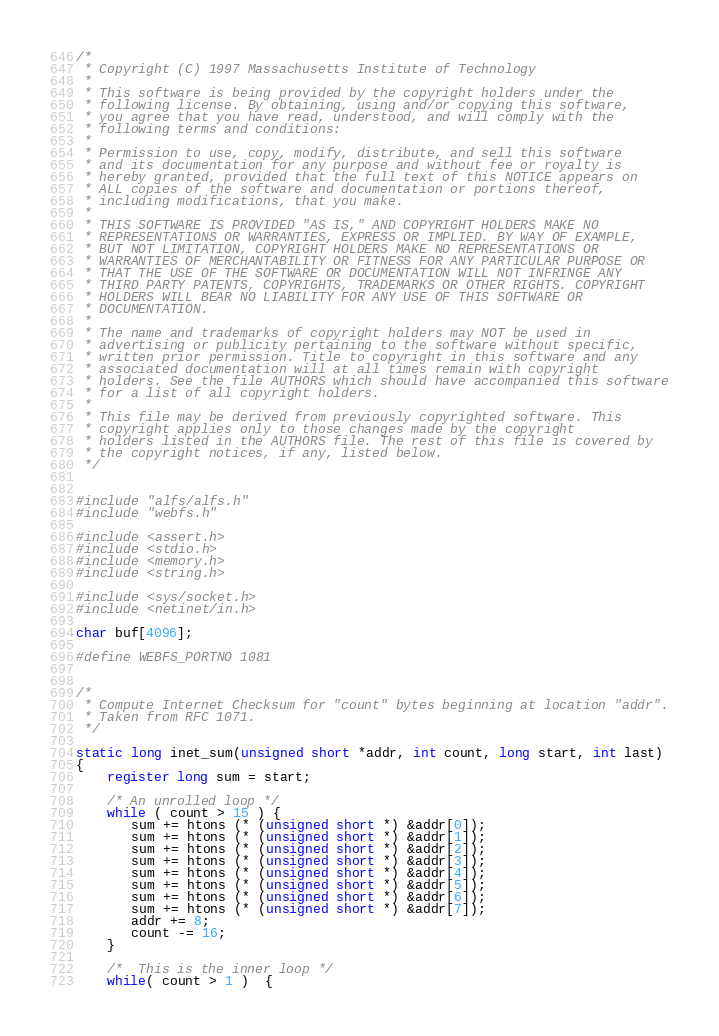Convert code to text. <code><loc_0><loc_0><loc_500><loc_500><_C_>
/*
 * Copyright (C) 1997 Massachusetts Institute of Technology 
 *
 * This software is being provided by the copyright holders under the
 * following license. By obtaining, using and/or copying this software,
 * you agree that you have read, understood, and will comply with the
 * following terms and conditions:
 *
 * Permission to use, copy, modify, distribute, and sell this software
 * and its documentation for any purpose and without fee or royalty is
 * hereby granted, provided that the full text of this NOTICE appears on
 * ALL copies of the software and documentation or portions thereof,
 * including modifications, that you make.
 *
 * THIS SOFTWARE IS PROVIDED "AS IS," AND COPYRIGHT HOLDERS MAKE NO
 * REPRESENTATIONS OR WARRANTIES, EXPRESS OR IMPLIED. BY WAY OF EXAMPLE,
 * BUT NOT LIMITATION, COPYRIGHT HOLDERS MAKE NO REPRESENTATIONS OR
 * WARRANTIES OF MERCHANTABILITY OR FITNESS FOR ANY PARTICULAR PURPOSE OR
 * THAT THE USE OF THE SOFTWARE OR DOCUMENTATION WILL NOT INFRINGE ANY
 * THIRD PARTY PATENTS, COPYRIGHTS, TRADEMARKS OR OTHER RIGHTS. COPYRIGHT
 * HOLDERS WILL BEAR NO LIABILITY FOR ANY USE OF THIS SOFTWARE OR
 * DOCUMENTATION.
 *
 * The name and trademarks of copyright holders may NOT be used in
 * advertising or publicity pertaining to the software without specific,
 * written prior permission. Title to copyright in this software and any
 * associated documentation will at all times remain with copyright
 * holders. See the file AUTHORS which should have accompanied this software
 * for a list of all copyright holders.
 *
 * This file may be derived from previously copyrighted software. This
 * copyright applies only to those changes made by the copyright
 * holders listed in the AUTHORS file. The rest of this file is covered by
 * the copyright notices, if any, listed below.
 */


#include "alfs/alfs.h"
#include "webfs.h"

#include <assert.h>
#include <stdio.h>
#include <memory.h>
#include <string.h>

#include <sys/socket.h>
#include <netinet/in.h>

char buf[4096];

#define WEBFS_PORTNO	1081


/*
 * Compute Internet Checksum for "count" bytes beginning at location "addr".
 * Taken from RFC 1071.
 */

static long inet_sum(unsigned short *addr, int count, long start, int last)
{
    register long sum = start;

    /* An unrolled loop */
    while ( count > 15 ) {
       sum += htons (* (unsigned short *) &addr[0]);
       sum += htons (* (unsigned short *) &addr[1]);
       sum += htons (* (unsigned short *) &addr[2]);
       sum += htons (* (unsigned short *) &addr[3]);
       sum += htons (* (unsigned short *) &addr[4]);
       sum += htons (* (unsigned short *) &addr[5]);
       sum += htons (* (unsigned short *) &addr[6]);
       sum += htons (* (unsigned short *) &addr[7]);
       addr += 8;
       count -= 16;
    }

    /*  This is the inner loop */
    while( count > 1 )  {</code> 